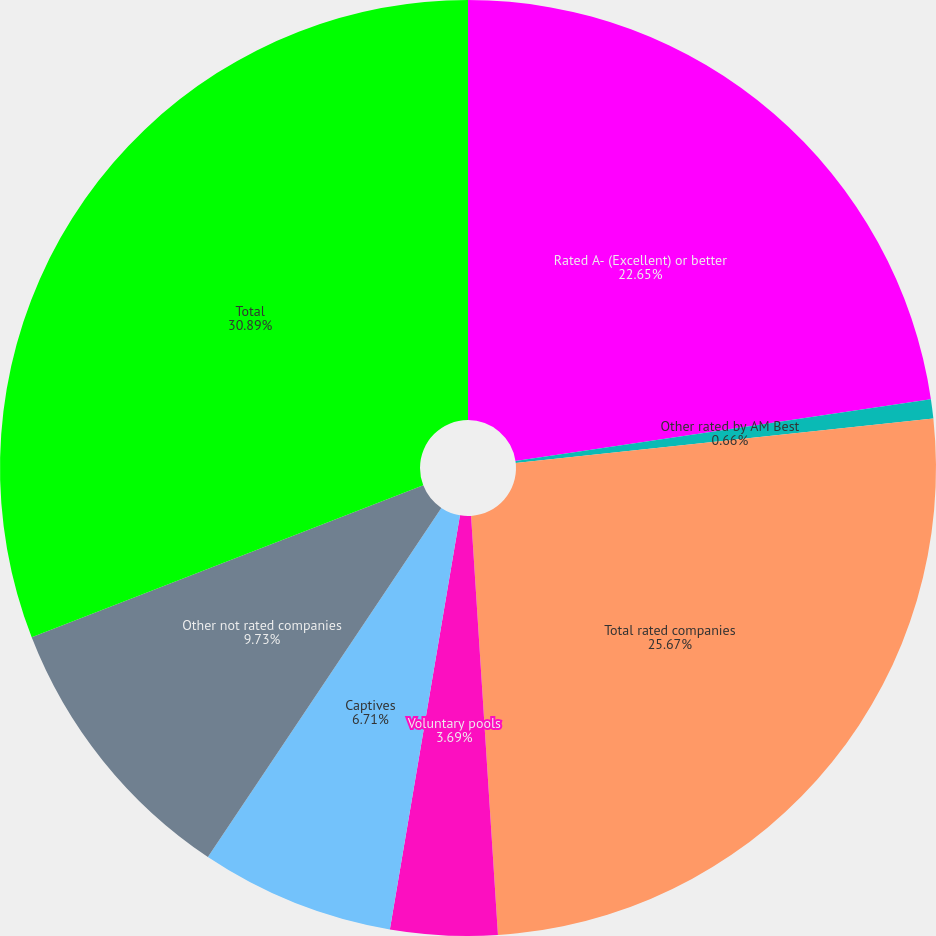<chart> <loc_0><loc_0><loc_500><loc_500><pie_chart><fcel>Rated A- (Excellent) or better<fcel>Other rated by AM Best<fcel>Total rated companies<fcel>Voluntary pools<fcel>Captives<fcel>Other not rated companies<fcel>Total<nl><fcel>22.65%<fcel>0.66%<fcel>25.67%<fcel>3.69%<fcel>6.71%<fcel>9.73%<fcel>30.89%<nl></chart> 